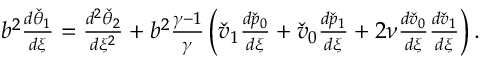Convert formula to latex. <formula><loc_0><loc_0><loc_500><loc_500>\begin{array} { r } { b ^ { 2 } \frac { d \check { \theta } _ { 1 } } { d \xi } = \frac { d ^ { 2 } \check { \theta } _ { 2 } } { d \xi ^ { 2 } } + b ^ { 2 } \frac { \gamma - 1 } { \gamma } \left ( \check { v } _ { 1 } \frac { d \check { p } _ { 0 } } { d \xi } + \check { v } _ { 0 } \frac { d \check { p } _ { 1 } } { d \xi } + 2 \nu \frac { d \check { v } _ { 0 } } { d \xi } \frac { d \check { v } _ { 1 } } { d \xi } \right ) . } \end{array}</formula> 